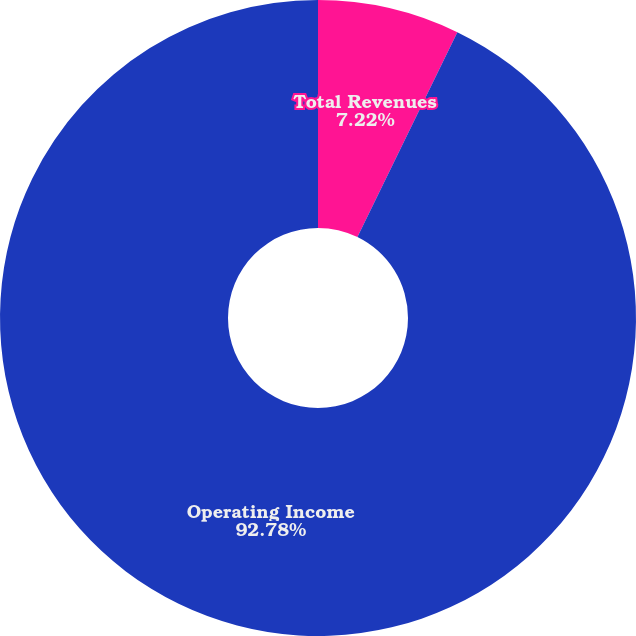Convert chart. <chart><loc_0><loc_0><loc_500><loc_500><pie_chart><fcel>Total Revenues<fcel>Operating Income<nl><fcel>7.22%<fcel>92.78%<nl></chart> 